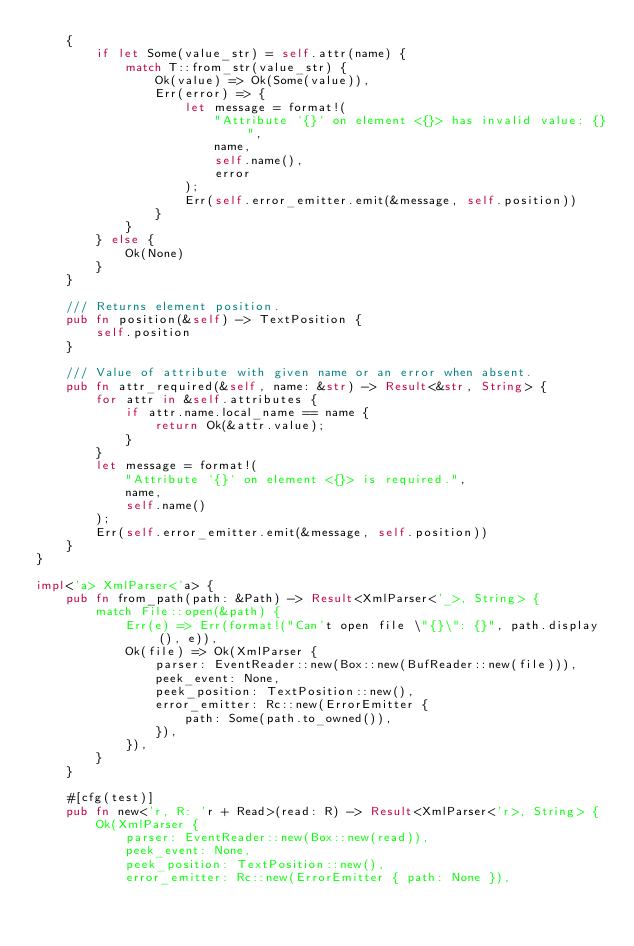Convert code to text. <code><loc_0><loc_0><loc_500><loc_500><_Rust_>    {
        if let Some(value_str) = self.attr(name) {
            match T::from_str(value_str) {
                Ok(value) => Ok(Some(value)),
                Err(error) => {
                    let message = format!(
                        "Attribute `{}` on element <{}> has invalid value: {}",
                        name,
                        self.name(),
                        error
                    );
                    Err(self.error_emitter.emit(&message, self.position))
                }
            }
        } else {
            Ok(None)
        }
    }

    /// Returns element position.
    pub fn position(&self) -> TextPosition {
        self.position
    }

    /// Value of attribute with given name or an error when absent.
    pub fn attr_required(&self, name: &str) -> Result<&str, String> {
        for attr in &self.attributes {
            if attr.name.local_name == name {
                return Ok(&attr.value);
            }
        }
        let message = format!(
            "Attribute `{}` on element <{}> is required.",
            name,
            self.name()
        );
        Err(self.error_emitter.emit(&message, self.position))
    }
}

impl<'a> XmlParser<'a> {
    pub fn from_path(path: &Path) -> Result<XmlParser<'_>, String> {
        match File::open(&path) {
            Err(e) => Err(format!("Can't open file \"{}\": {}", path.display(), e)),
            Ok(file) => Ok(XmlParser {
                parser: EventReader::new(Box::new(BufReader::new(file))),
                peek_event: None,
                peek_position: TextPosition::new(),
                error_emitter: Rc::new(ErrorEmitter {
                    path: Some(path.to_owned()),
                }),
            }),
        }
    }

    #[cfg(test)]
    pub fn new<'r, R: 'r + Read>(read: R) -> Result<XmlParser<'r>, String> {
        Ok(XmlParser {
            parser: EventReader::new(Box::new(read)),
            peek_event: None,
            peek_position: TextPosition::new(),
            error_emitter: Rc::new(ErrorEmitter { path: None }),</code> 